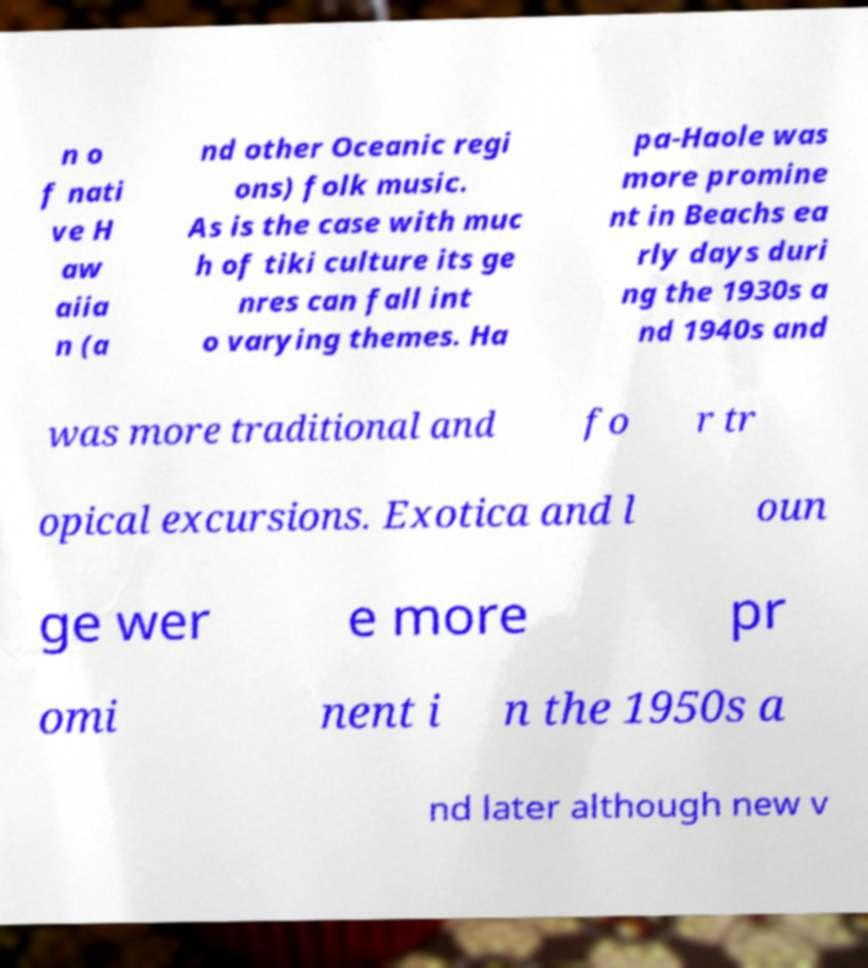Can you read and provide the text displayed in the image?This photo seems to have some interesting text. Can you extract and type it out for me? n o f nati ve H aw aiia n (a nd other Oceanic regi ons) folk music. As is the case with muc h of tiki culture its ge nres can fall int o varying themes. Ha pa-Haole was more promine nt in Beachs ea rly days duri ng the 1930s a nd 1940s and was more traditional and fo r tr opical excursions. Exotica and l oun ge wer e more pr omi nent i n the 1950s a nd later although new v 